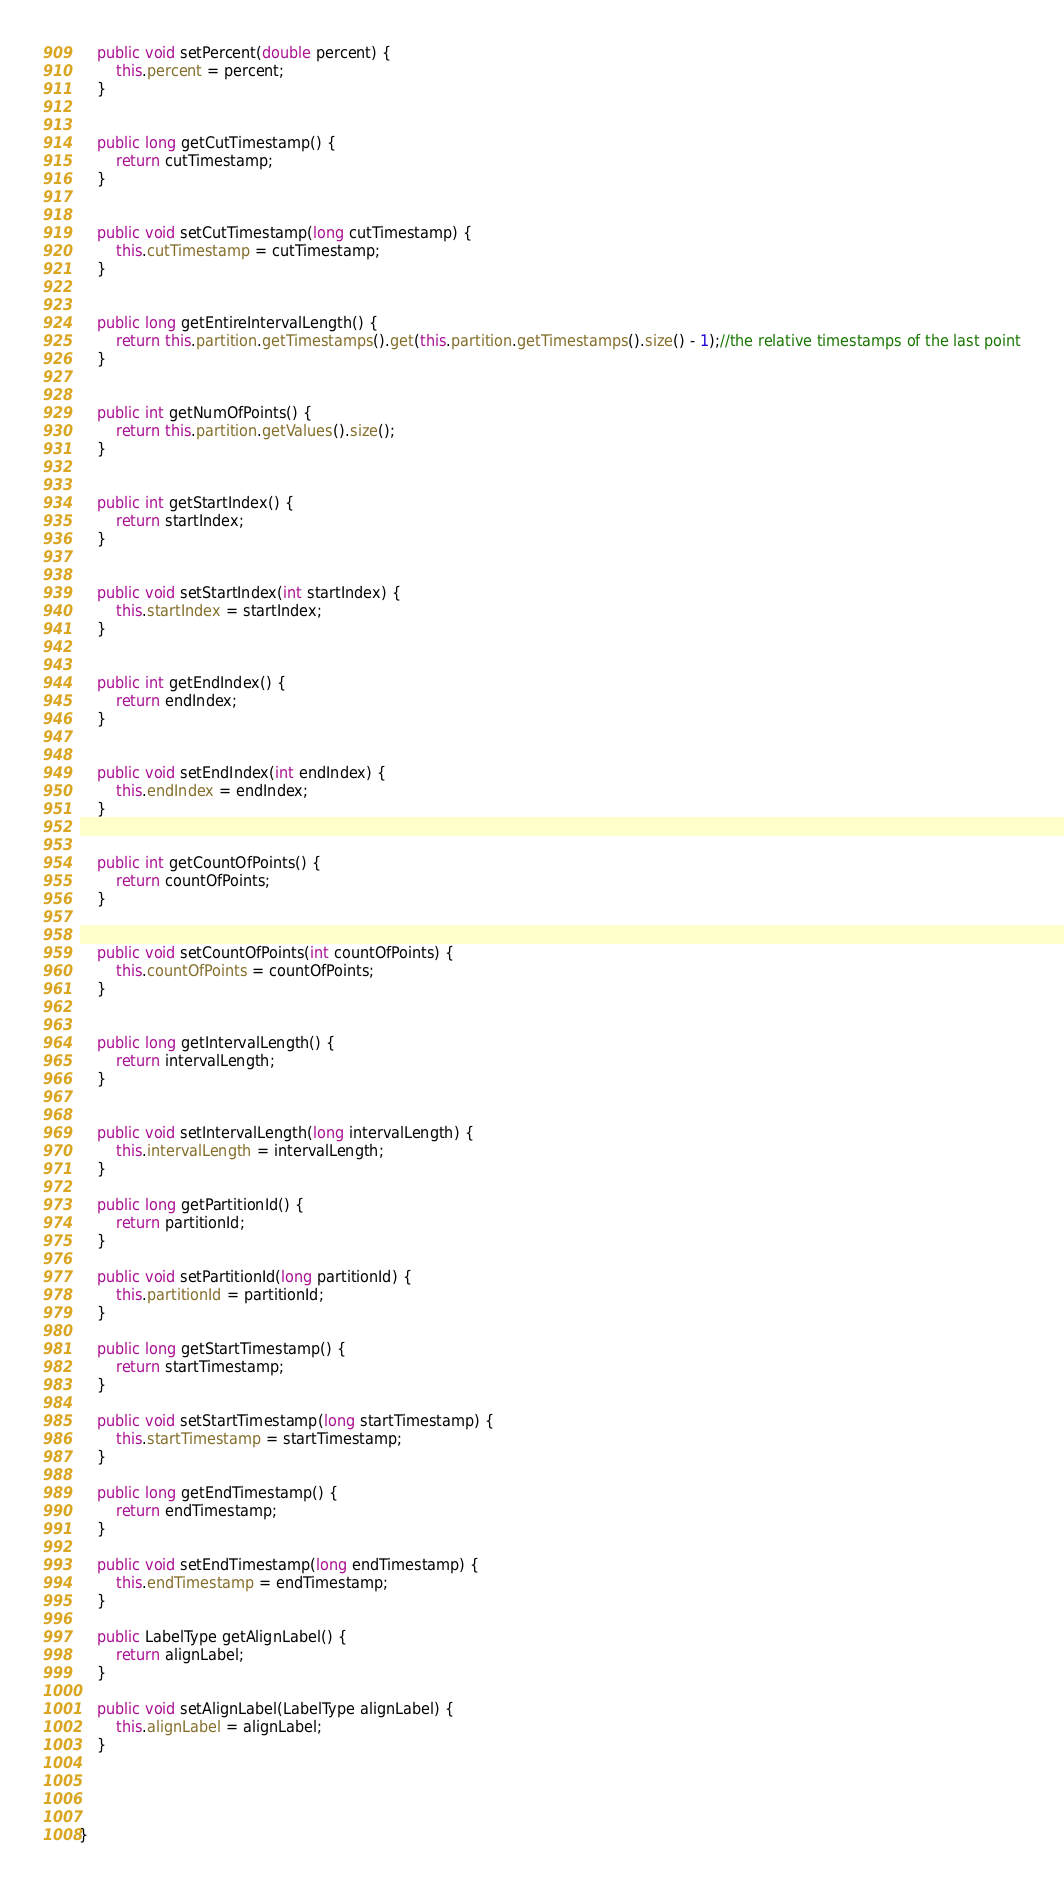<code> <loc_0><loc_0><loc_500><loc_500><_Java_>

	public void setPercent(double percent) {
		this.percent = percent;
	}


	public long getCutTimestamp() {
		return cutTimestamp;
	}


	public void setCutTimestamp(long cutTimestamp) {
		this.cutTimestamp = cutTimestamp;
	}


	public long getEntireIntervalLength() {
		return this.partition.getTimestamps().get(this.partition.getTimestamps().size() - 1);//the relative timestamps of the last point
	}


	public int getNumOfPoints() {
		return this.partition.getValues().size();
	}


	public int getStartIndex() {
		return startIndex;
	}


	public void setStartIndex(int startIndex) {
		this.startIndex = startIndex;
	}


	public int getEndIndex() {
		return endIndex;
	}


	public void setEndIndex(int endIndex) {
		this.endIndex = endIndex;
	}


	public int getCountOfPoints() {
		return countOfPoints;
	}


	public void setCountOfPoints(int countOfPoints) {
		this.countOfPoints = countOfPoints;
	}


	public long getIntervalLength() {
		return intervalLength;
	}


	public void setIntervalLength(long intervalLength) {
		this.intervalLength = intervalLength;
	}

	public long getPartitionId() {
		return partitionId;
	}

	public void setPartitionId(long partitionId) {
		this.partitionId = partitionId;
	}

	public long getStartTimestamp() {
		return startTimestamp;
	}

	public void setStartTimestamp(long startTimestamp) {
		this.startTimestamp = startTimestamp;
	}

	public long getEndTimestamp() {
		return endTimestamp;
	}

	public void setEndTimestamp(long endTimestamp) {
		this.endTimestamp = endTimestamp;
	}

	public LabelType getAlignLabel() {
		return alignLabel;
	}

	public void setAlignLabel(LabelType alignLabel) {
		this.alignLabel = alignLabel;
	}



	
}
</code> 